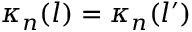<formula> <loc_0><loc_0><loc_500><loc_500>\kappa _ { n } ( l ) = \kappa _ { n } ( l ^ { \prime } )</formula> 